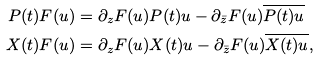<formula> <loc_0><loc_0><loc_500><loc_500>P ( t ) F ( u ) & = \partial _ { z } F ( u ) P ( t ) u - \partial _ { \bar { z } } F ( u ) \overline { P ( t ) u } \\ X ( t ) F ( u ) & = \partial _ { z } F ( u ) X ( t ) u - \partial _ { \bar { z } } F ( u ) \overline { X ( t ) u } ,</formula> 